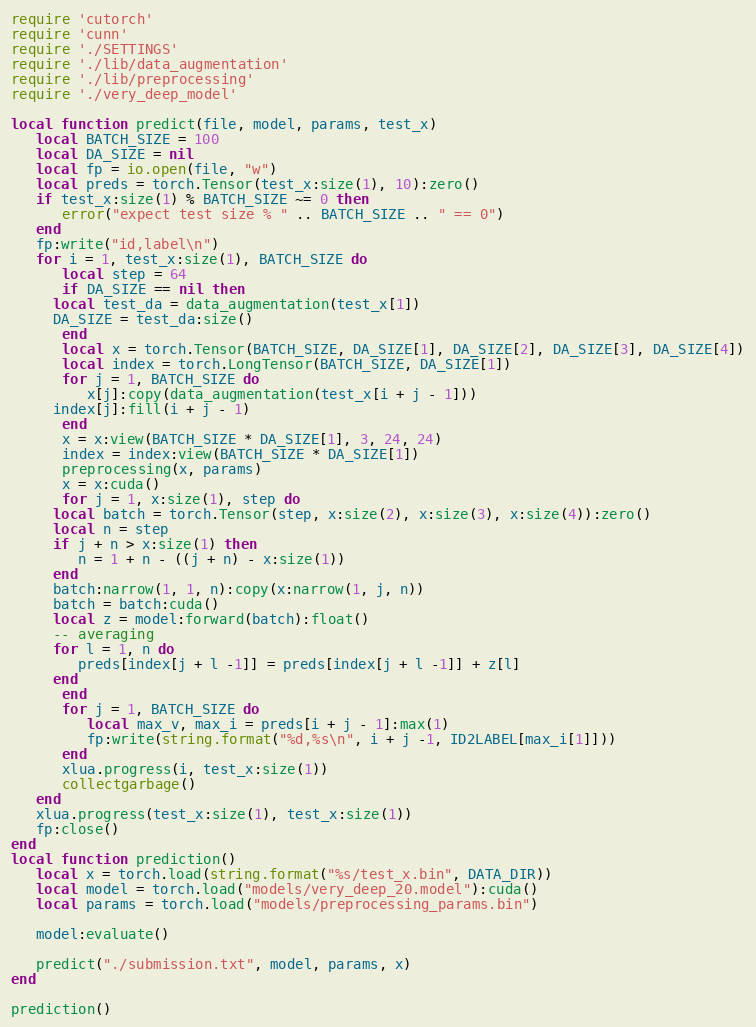<code> <loc_0><loc_0><loc_500><loc_500><_Lua_>require 'cutorch'
require 'cunn'
require './SETTINGS'
require './lib/data_augmentation'
require './lib/preprocessing'
require './very_deep_model'

local function predict(file, model, params, test_x)
   local BATCH_SIZE = 100
   local DA_SIZE = nil
   local fp = io.open(file, "w")
   local preds = torch.Tensor(test_x:size(1), 10):zero()
   if test_x:size(1) % BATCH_SIZE ~= 0 then
      error("expect test size % " .. BATCH_SIZE .. " == 0")
   end
   fp:write("id,label\n")
   for i = 1, test_x:size(1), BATCH_SIZE do
      local step = 64
      if DA_SIZE == nil then
	 local test_da = data_augmentation(test_x[1])
	 DA_SIZE = test_da:size()
      end
      local x = torch.Tensor(BATCH_SIZE, DA_SIZE[1], DA_SIZE[2], DA_SIZE[3], DA_SIZE[4])
      local index = torch.LongTensor(BATCH_SIZE, DA_SIZE[1])
      for j = 1, BATCH_SIZE do
         x[j]:copy(data_augmentation(test_x[i + j - 1]))
	 index[j]:fill(i + j - 1)
      end
      x = x:view(BATCH_SIZE * DA_SIZE[1], 3, 24, 24)
      index = index:view(BATCH_SIZE * DA_SIZE[1])
      preprocessing(x, params)
      x = x:cuda()
      for j = 1, x:size(1), step do
	 local batch = torch.Tensor(step, x:size(2), x:size(3), x:size(4)):zero()
	 local n = step
	 if j + n > x:size(1) then
	    n = 1 + n - ((j + n) - x:size(1))
	 end
	 batch:narrow(1, 1, n):copy(x:narrow(1, j, n))
	 batch = batch:cuda()
	 local z = model:forward(batch):float()
	 -- averaging
	 for l = 1, n do
	    preds[index[j + l -1]] = preds[index[j + l -1]] + z[l]
	 end
      end
      for j = 1, BATCH_SIZE do
         local max_v, max_i = preds[i + j - 1]:max(1)
         fp:write(string.format("%d,%s\n", i + j -1, ID2LABEL[max_i[1]]))
      end
      xlua.progress(i, test_x:size(1))
      collectgarbage()
   end
   xlua.progress(test_x:size(1), test_x:size(1))
   fp:close()
end
local function prediction()
   local x = torch.load(string.format("%s/test_x.bin", DATA_DIR))
   local model = torch.load("models/very_deep_20.model"):cuda()
   local params = torch.load("models/preprocessing_params.bin")

   model:evaluate()
   
   predict("./submission.txt", model, params, x)
end

prediction()
</code> 